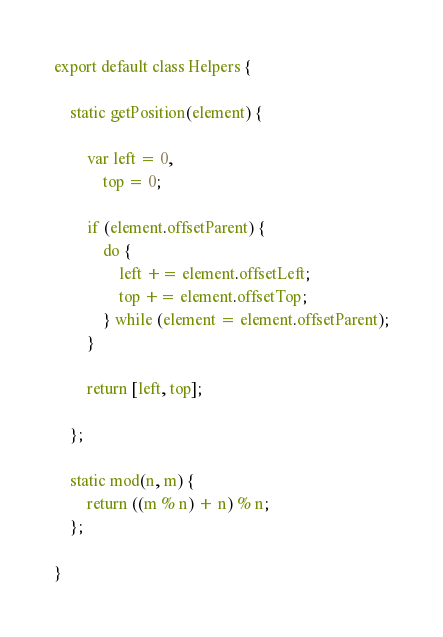Convert code to text. <code><loc_0><loc_0><loc_500><loc_500><_JavaScript_>export default class Helpers {

    static getPosition(element) {

        var left = 0,
            top = 0;

        if (element.offsetParent) {
            do {
                left += element.offsetLeft;
                top += element.offsetTop;
            } while (element = element.offsetParent);
        }

        return [left, top];

    };

    static mod(n, m) {
        return ((m % n) + n) % n;
    };

}
</code> 